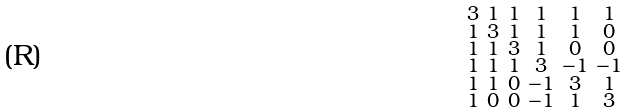Convert formula to latex. <formula><loc_0><loc_0><loc_500><loc_500>\begin{smallmatrix} 3 & 1 & 1 & 1 & 1 & 1 \\ 1 & 3 & 1 & 1 & 1 & 0 \\ 1 & 1 & 3 & 1 & 0 & 0 \\ 1 & 1 & 1 & 3 & - 1 & - 1 \\ 1 & 1 & 0 & - 1 & 3 & 1 \\ 1 & 0 & 0 & - 1 & 1 & 3 \end{smallmatrix}</formula> 